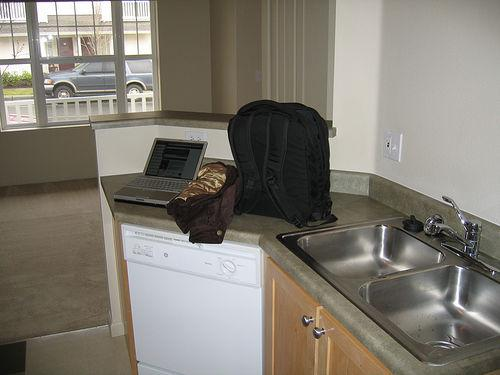Where is someone working?

Choices:
A) home
B) library
C) office
D) courthouse home 